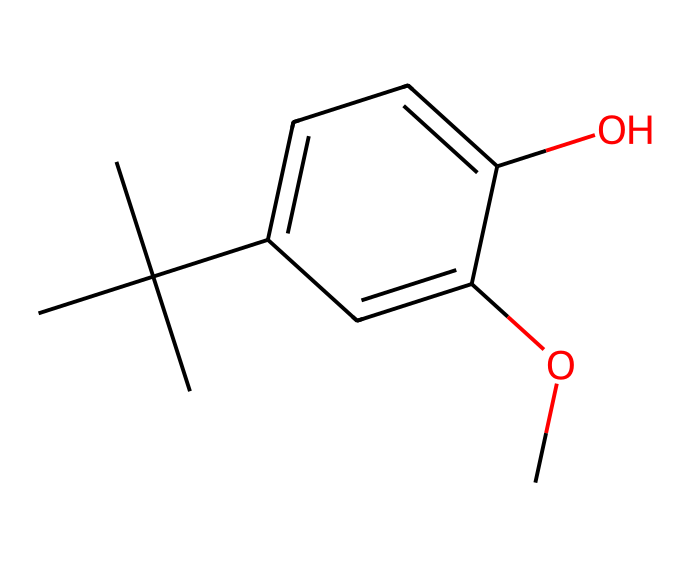What is the molecular formula of butylated hydroxyanisole (BHA)? To determine the molecular formula, count all the carbon (C), hydrogen (H), and oxygen (O) atoms in the SMILES representation. The chemical has 11 carbon atoms, 14 hydrogen atoms, and 2 oxygen atoms, leading to the formula C11H14O2.
Answer: C11H14O2 How many aromatic rings are present in this structure? The chemical structure contains one aromatic ring which can be identified by the presence of alternating double bonds in the cyclic part of the molecule.
Answer: 1 What functional groups are present in BHA? Analyzing the chemical structure, BHA contains a methoxy group (-OCH3) and a hydroxyl group (-OH) indicating the presence of both ether and alcohol functional groups.
Answer: methoxy and hydroxyl Which element has the highest concentration in BHA? By counting the atoms, we find that there are more carbon (C) atoms (11) than hydrogen (H) atoms (14) or oxygen (O) atoms (2), indicating that carbon is the most abundant element in the molecule.
Answer: carbon Is BHA a polar or non-polar compound? To determine polarity, we consider the presence of polar functional groups such as hydroxyl. However, due to the predominant hydrocarbon character from the carbon chains, the molecule can be considered predominantly non-polar despite containing polar groups.
Answer: non-polar How many oxygen atoms are present in BHA? From the molecular formula or the breakdown of the chemical structure, we can see that there are 2 oxygen atoms.
Answer: 2 